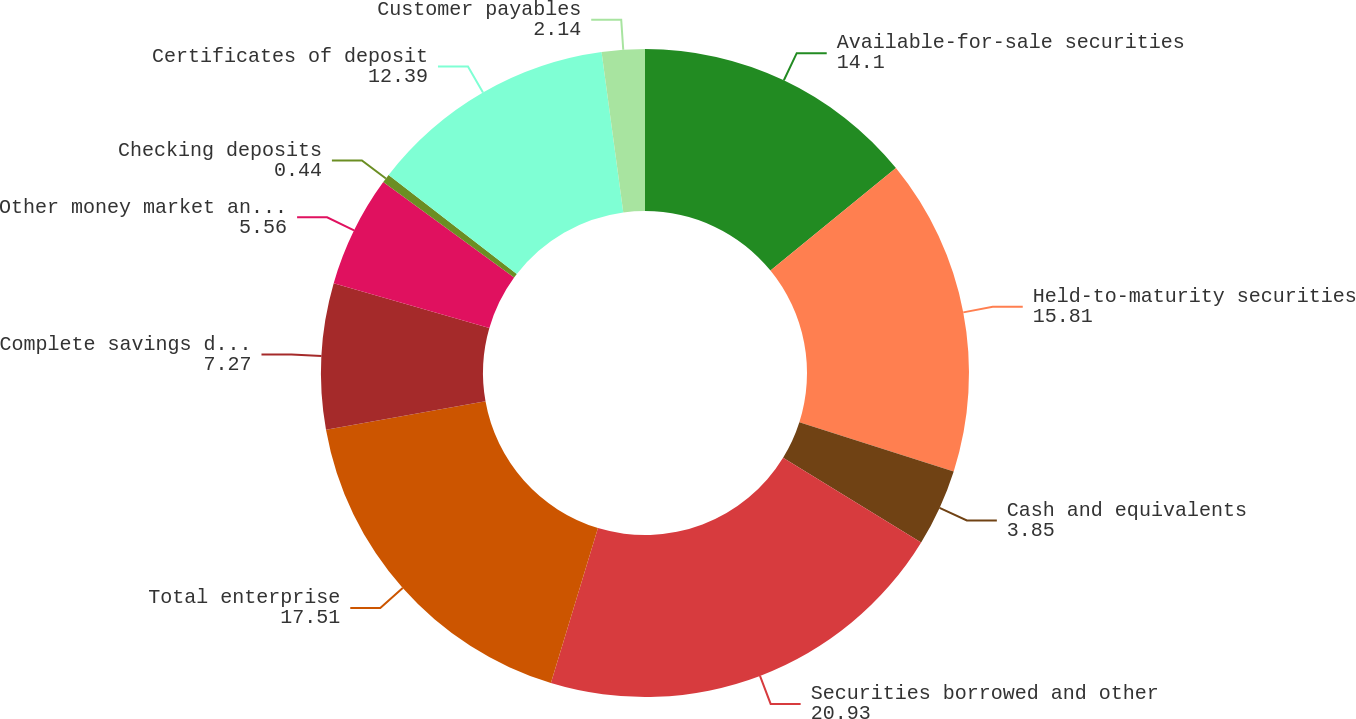Convert chart to OTSL. <chart><loc_0><loc_0><loc_500><loc_500><pie_chart><fcel>Available-for-sale securities<fcel>Held-to-maturity securities<fcel>Cash and equivalents<fcel>Securities borrowed and other<fcel>Total enterprise<fcel>Complete savings deposits<fcel>Other money market and savings<fcel>Checking deposits<fcel>Certificates of deposit<fcel>Customer payables<nl><fcel>14.1%<fcel>15.81%<fcel>3.85%<fcel>20.93%<fcel>17.51%<fcel>7.27%<fcel>5.56%<fcel>0.44%<fcel>12.39%<fcel>2.14%<nl></chart> 